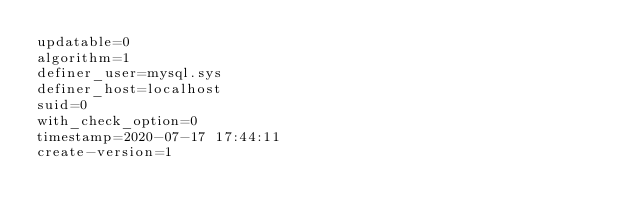Convert code to text. <code><loc_0><loc_0><loc_500><loc_500><_VisualBasic_>updatable=0
algorithm=1
definer_user=mysql.sys
definer_host=localhost
suid=0
with_check_option=0
timestamp=2020-07-17 17:44:11
create-version=1</code> 